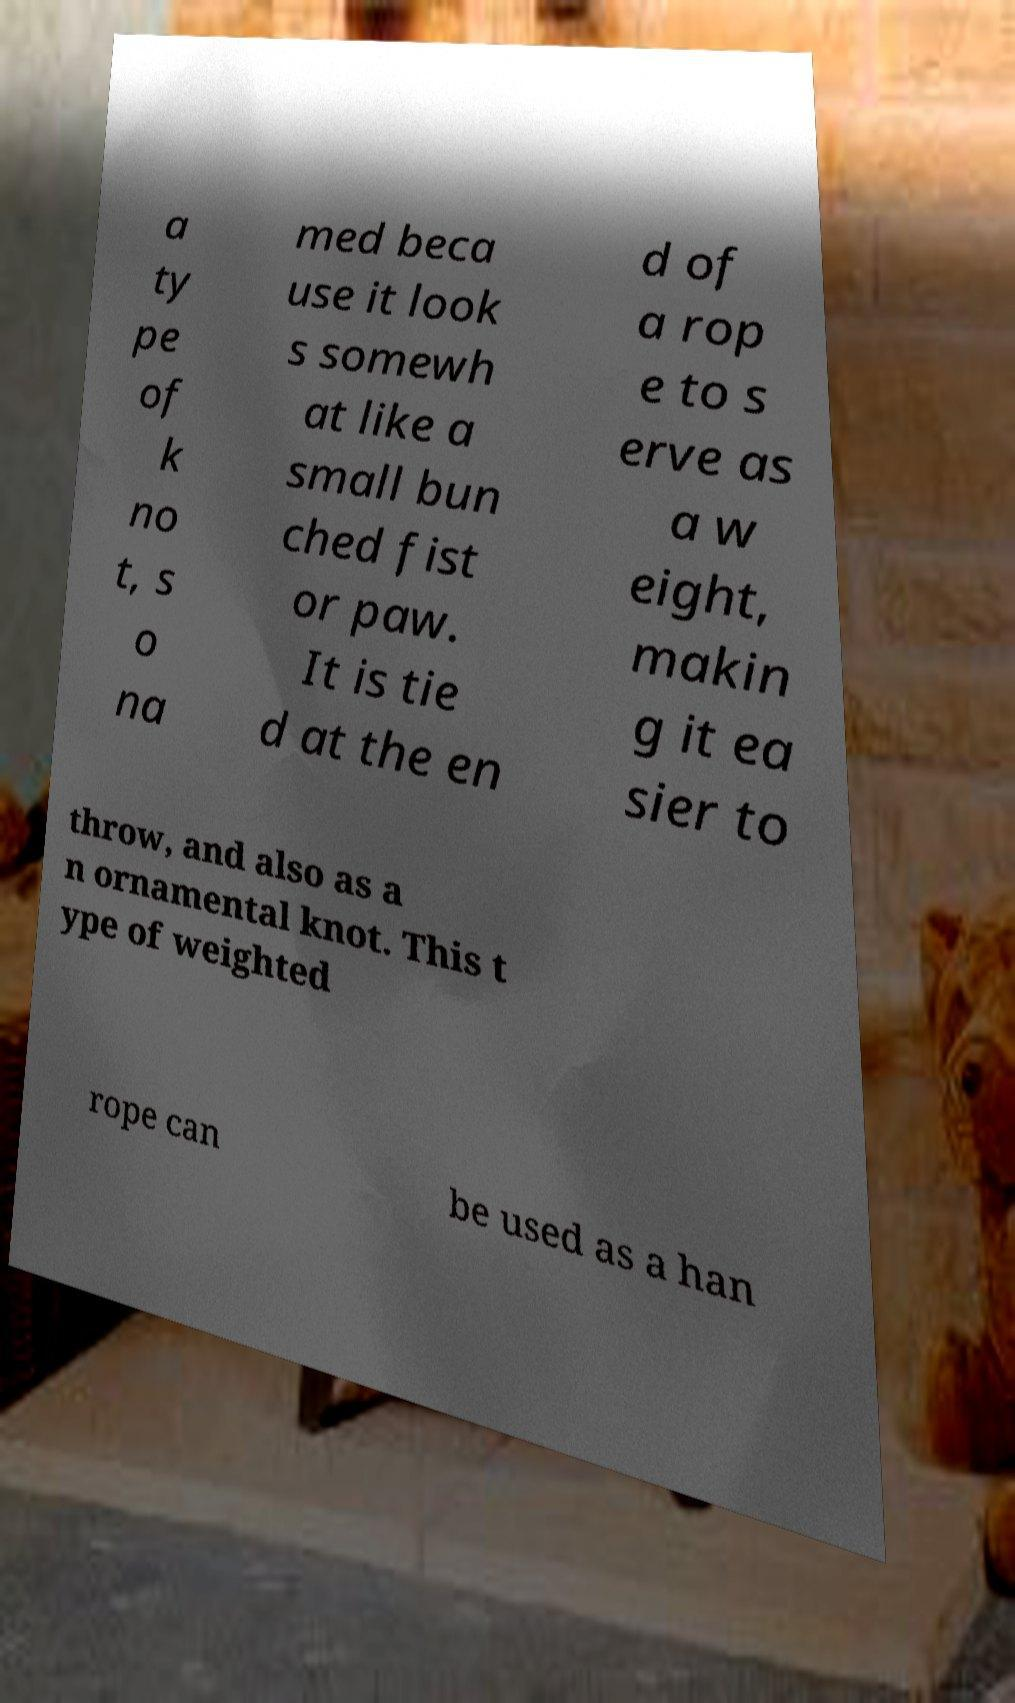There's text embedded in this image that I need extracted. Can you transcribe it verbatim? a ty pe of k no t, s o na med beca use it look s somewh at like a small bun ched fist or paw. It is tie d at the en d of a rop e to s erve as a w eight, makin g it ea sier to throw, and also as a n ornamental knot. This t ype of weighted rope can be used as a han 